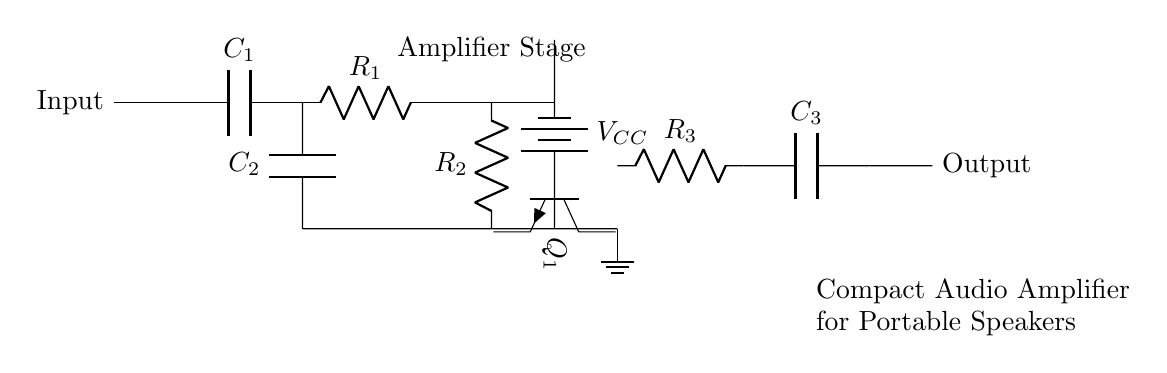What components are used in the amplifier stage? The amplifier stage includes two resistors, labeled R1 and R2, and a transistor, labeled Q1. These components work together to amplify the input signal.
Answer: R1, R2, Q1 What type of transistor is used in this circuit? The diagram shows an NPN transistor, indicated by the label Q1 and symbol in the circuit. NPN transistors are commonly used in amplification circuits due to their characteristics.
Answer: NPN How many capacitors are present in the circuit? The circuit contains three capacitors: C1, C2, and C3. Each of these capacitors plays a role in filtering or coupling signals within the amplifier circuit.
Answer: 3 What is the role of the resistor R3? R3 acts as a load resistor in the output stage, affecting the signal amplitude and helping to stabilize the output voltage for the connected portable speakers.
Answer: Load resistor What is the voltage source labeled in the circuit? The voltage source is denoted as VCC, and it provides the necessary power to the amplifier circuit for operation.
Answer: VCC Which component is responsible for input filtering? The capacitor C1 is responsible for input filtering, smoothing the incoming signal to avoid distortion and allow for better amplification in the following stages.
Answer: C1 What is the purpose of capacitor C3? Capacitor C3 serves as a coupling capacitor, allowing AC signals to pass while blocking DC components, which helps to prevent DC offset in the audio output.
Answer: Coupling capacitor 